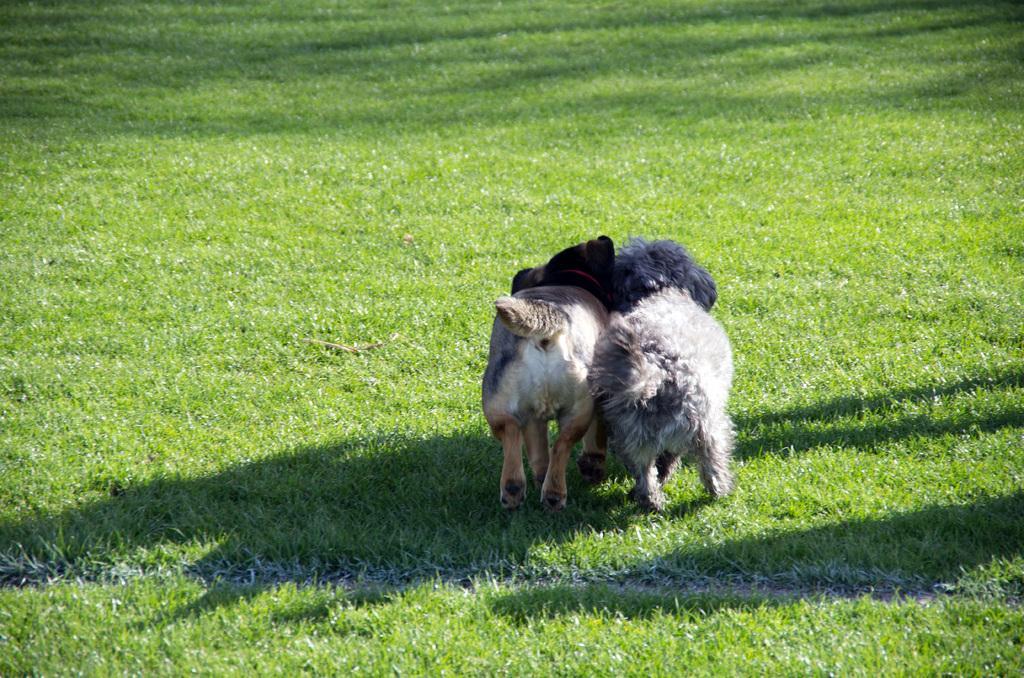Can you describe this image briefly? In this image there are two dogs present on the grass. 